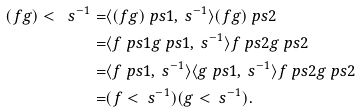Convert formula to latex. <formula><loc_0><loc_0><loc_500><loc_500>( f g ) < \ s ^ { - 1 } = & \langle ( f g ) \ p s { 1 } , \ s ^ { - 1 } \rangle ( f g ) \ p s { 2 } \\ = & \langle f \ p s { 1 } g \ p s { 1 } , \ s ^ { - 1 } \rangle f \ p s { 2 } g \ p s { 2 } \\ = & \langle f \ p s { 1 } , \ s ^ { - 1 } \rangle \langle g \ p s { 1 } , \ s ^ { - 1 } \rangle f \ p s { 2 } g \ p s { 2 } \\ = & ( f < \ s ^ { - 1 } ) ( g < \ s ^ { - 1 } ) .</formula> 